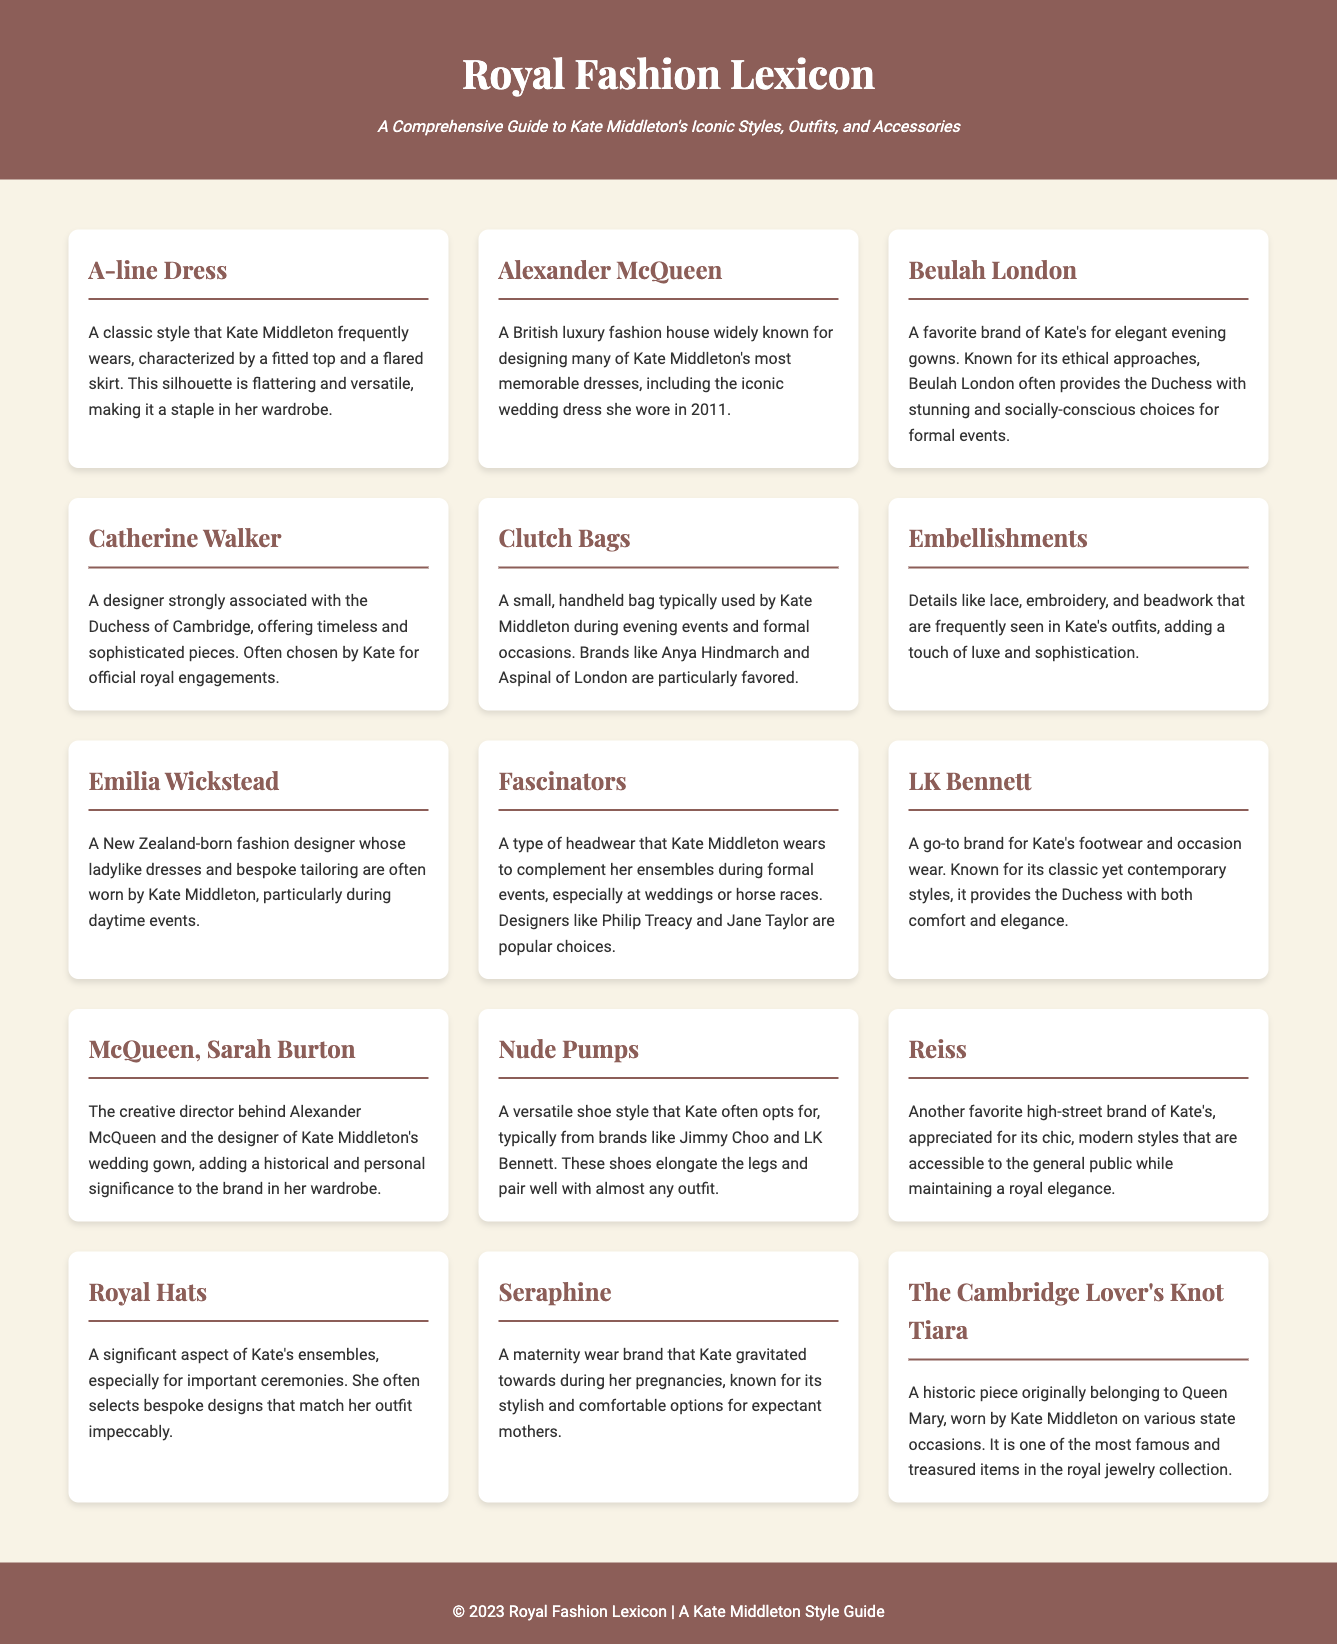What is an A-line Dress? An A-line dress is a classic style that Kate Middleton frequently wears, characterized by a fitted top and a flared skirt, making it a staple in her wardrobe.
Answer: A-line Dress Who designed Kate Middleton's wedding dress? The wedding dress worn by Kate Middleton was designed by Alexander McQueen.
Answer: Alexander McQueen Which brand is known for offering socially-conscious evening gowns for Kate? Beulah London is known for its ethical approaches and provides the Duchess with elegant evening gowns.
Answer: Beulah London What type of headwear is associated with Kate Middleton? Fascinators are a type of headwear that Kate Middleton wears to complement her outfits during formal events.
Answer: Fascinators Which footwear brand is commonly worn by Kate Middleton? LK Bennett is a go-to brand for Kate's footwear and occasion wear.
Answer: LK Bennett What is the significance of the Cambridge Lover's Knot Tiara? The Cambridge Lover's Knot Tiara is a historic piece originally belonging to Queen Mary, worn by Kate Middleton on state occasions.
Answer: The Cambridge Lover's Knot Tiara Which designer is associated with bespoke tailoring for Kate? Catherine Walker is a designer strongly associated with the Duchess of Cambridge, offering timeless and sophisticated pieces.
Answer: Catherine Walker What type of shoes does Kate often choose for their versatility? Nude pumps are a shoe style that Kate often opts for, known for elongating the legs.
Answer: Nude Pumps Which high-street brand is favored by Kate for modern styles? Reiss is another favorite high-street brand of Kate's, appreciated for its chic, modern styles.
Answer: Reiss 